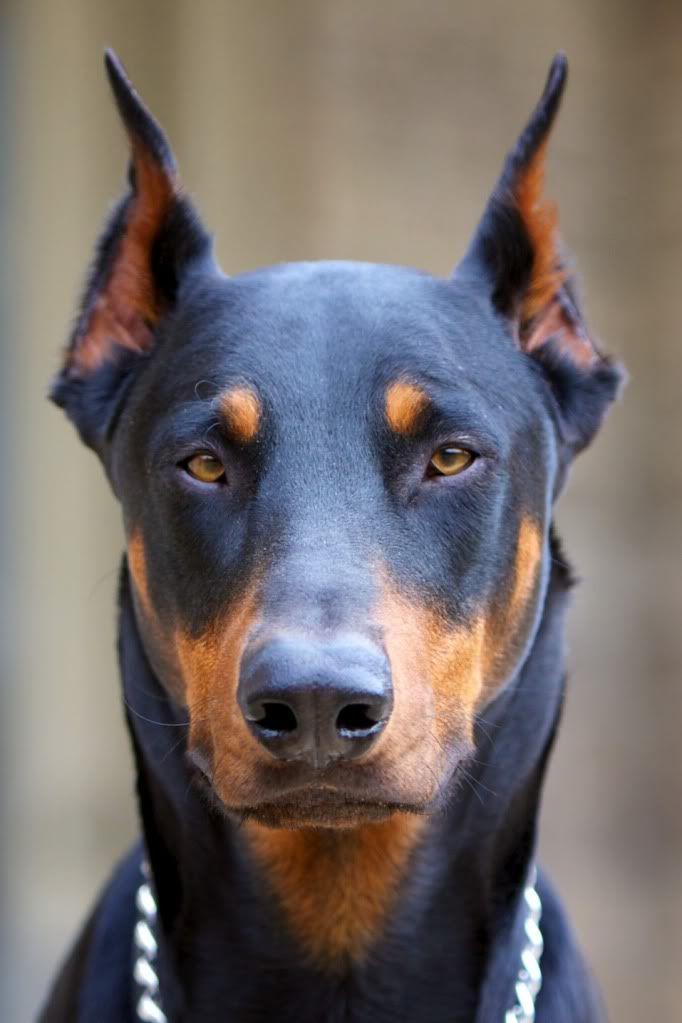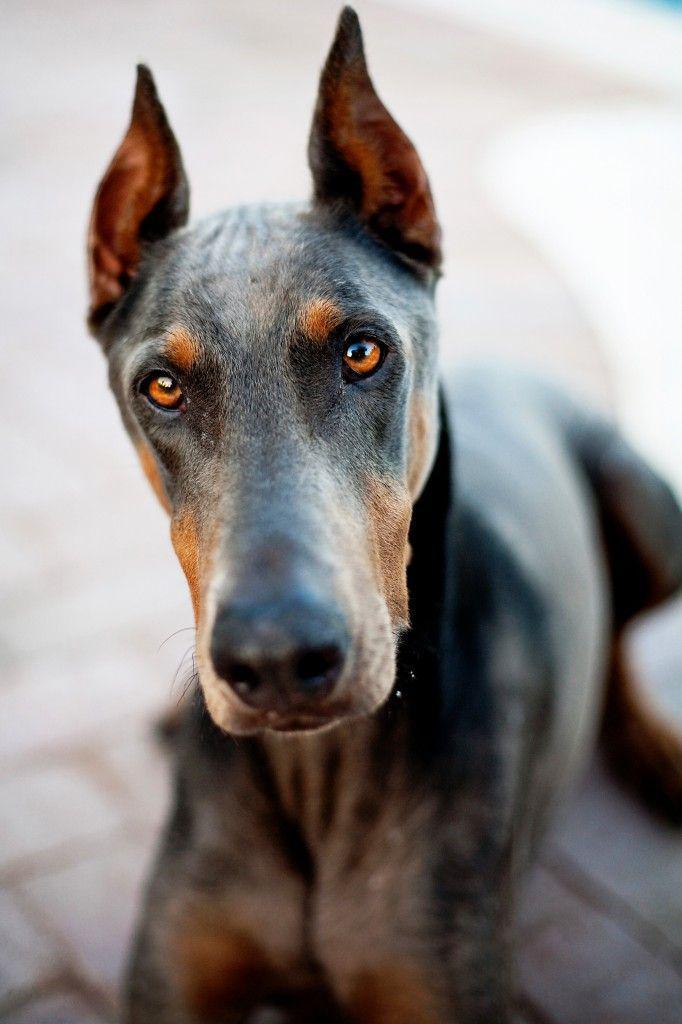The first image is the image on the left, the second image is the image on the right. For the images displayed, is the sentence "Each image shows one forward-facing adult doberman with pointy erect ears." factually correct? Answer yes or no. Yes. The first image is the image on the left, the second image is the image on the right. Examine the images to the left and right. Is the description "The ears of two dobermans are sticking straight up." accurate? Answer yes or no. Yes. 